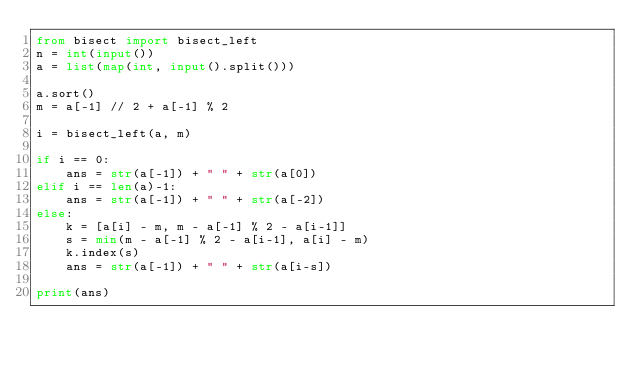<code> <loc_0><loc_0><loc_500><loc_500><_Python_>from bisect import bisect_left
n = int(input())
a = list(map(int, input().split()))

a.sort()
m = a[-1] // 2 + a[-1] % 2

i = bisect_left(a, m)

if i == 0:
    ans = str(a[-1]) + " " + str(a[0])
elif i == len(a)-1:
    ans = str(a[-1]) + " " + str(a[-2])
else:
    k = [a[i] - m, m - a[-1] % 2 - a[i-1]]
    s = min(m - a[-1] % 2 - a[i-1], a[i] - m)
    k.index(s)
    ans = str(a[-1]) + " " + str(a[i-s])     

print(ans)</code> 